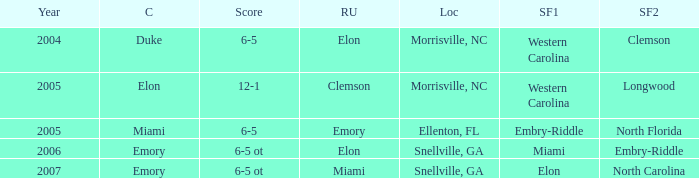List the scores of all games when Miami were listed as the first Semi finalist 6-5 ot. 